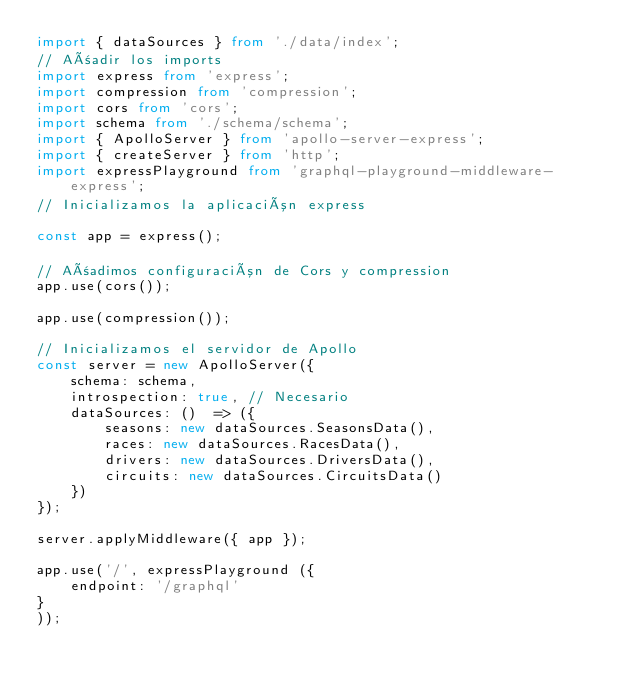Convert code to text. <code><loc_0><loc_0><loc_500><loc_500><_TypeScript_>import { dataSources } from './data/index';
// Añadir los imports
import express from 'express';
import compression from 'compression';
import cors from 'cors';
import schema from './schema/schema';
import { ApolloServer } from 'apollo-server-express';
import { createServer } from 'http';
import expressPlayground from 'graphql-playground-middleware-express';
// Inicializamos la aplicación express

const app = express();

// Añadimos configuración de Cors y compression
app.use(cors());

app.use(compression());

// Inicializamos el servidor de Apollo
const server = new ApolloServer({
    schema: schema,
    introspection: true, // Necesario
    dataSources: ()  => ({
        seasons: new dataSources.SeasonsData(),
        races: new dataSources.RacesData(),
        drivers: new dataSources.DriversData(),
        circuits: new dataSources.CircuitsData()
    })
});

server.applyMiddleware({ app });

app.use('/', expressPlayground ({
    endpoint: '/graphql'
}
));</code> 